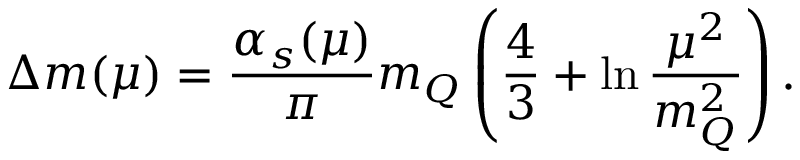<formula> <loc_0><loc_0><loc_500><loc_500>\Delta m ( \mu ) = \frac { \alpha _ { s } ( \mu ) } { \pi } m _ { Q } \left ( \frac { 4 } { 3 } + \ln \frac { \mu ^ { 2 } } { m _ { Q } ^ { 2 } } \right ) .</formula> 